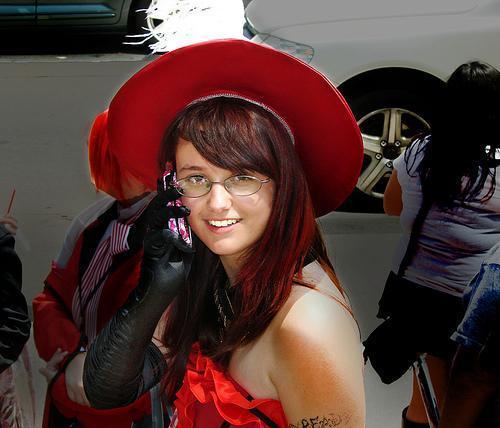How many women are in the foreground?
Give a very brief answer. 1. How many tires are visible?
Give a very brief answer. 1. How many girls are in the photo?
Give a very brief answer. 2. 